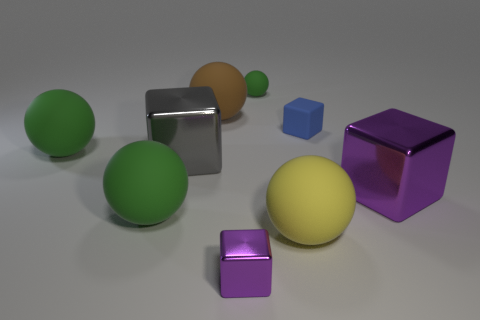Is there a large metallic object that has the same shape as the brown rubber thing?
Your answer should be compact. No. How many objects are either purple things that are left of the big yellow object or green balls?
Give a very brief answer. 4. The other thing that is the same color as the small metallic thing is what size?
Provide a short and direct response. Large. There is a tiny object in front of the small rubber block; does it have the same color as the big matte thing that is on the right side of the small rubber sphere?
Make the answer very short. No. What size is the blue cube?
Your answer should be compact. Small. What number of big objects are either yellow matte balls or brown balls?
Offer a very short reply. 2. There is another metal thing that is the same size as the gray metal thing; what color is it?
Give a very brief answer. Purple. How many other objects are there of the same shape as the brown rubber thing?
Provide a short and direct response. 4. Are there any big purple things made of the same material as the yellow object?
Your answer should be very brief. No. Are the purple thing left of the large yellow rubber ball and the brown sphere behind the large purple metallic thing made of the same material?
Provide a succinct answer. No. 